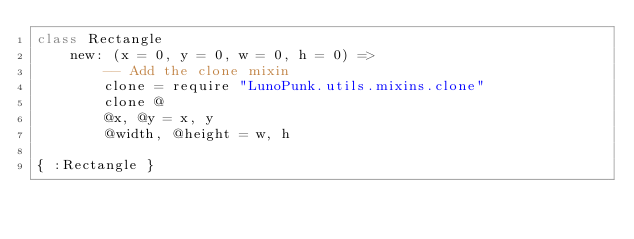Convert code to text. <code><loc_0><loc_0><loc_500><loc_500><_MoonScript_>class Rectangle
	new: (x = 0, y = 0, w = 0, h = 0) =>
		-- Add the clone mixin
		clone = require "LunoPunk.utils.mixins.clone"
		clone @
		@x, @y = x, y
		@width, @height = w, h

{ :Rectangle }
</code> 